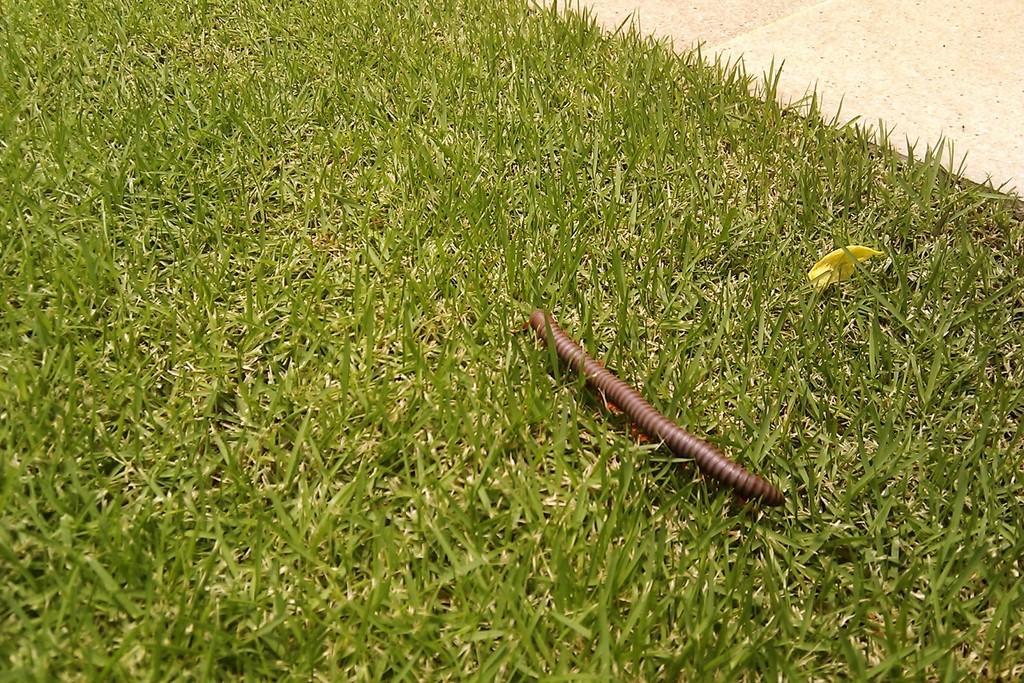Please provide a concise description of this image. In this image, this looks like a millipedes insect. This is the grass. I think this is the pathway. 